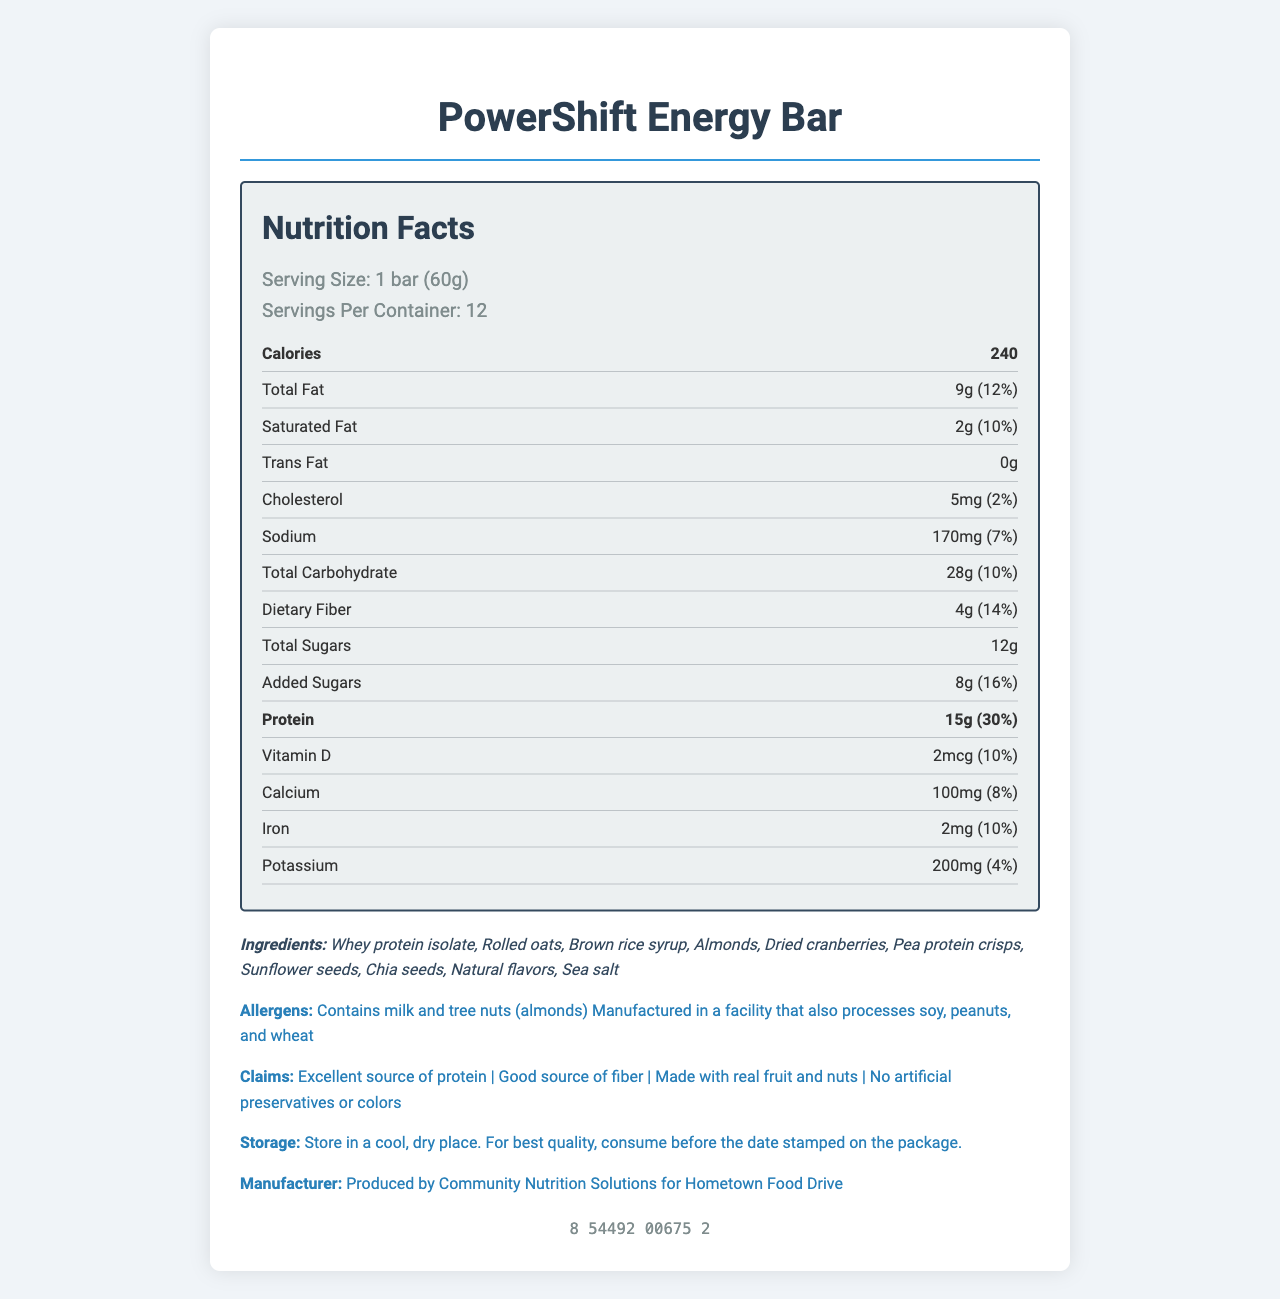What is the serving size for the PowerShift Energy Bar? The document specifies that the serving size of the PowerShift Energy Bar is "1 bar (60g)" under the 'serving info' section.
Answer: 1 bar (60g) How many servings are there per container? The document states there are 12 servings per container, as seen under the 'serving info' section.
Answer: 12 How many calories are there per serving? The document specifies that there are 240 calories per serving in the 'nutrition label' section.
Answer: 240 What are the total fat and its daily value percentage per serving? The document states that the total fat content per serving is 9g and this represents 12% of the daily value.
Answer: 9g (12%) What are the dietary fiber and its daily value percentage per serving? The document shows that the dietary fiber content per serving is 4g, which is 14% of the daily value.
Answer: 4g (14%) What ingredients does the PowerShift Energy Bar contain? The document lists the ingredients under the 'ingredients' section.
Answer: Whey protein isolate, Rolled oats, Brown rice syrup, Almonds, Dried cranberries, Pea protein crisps, Sunflower seeds, Chia seeds, Natural flavors, Sea salt What allergens are identified in the product? The document states the allergens in the 'allergens' section.
Answer: Contains milk and tree nuts (almonds), Manufactured in a facility that also processes soy, peanuts, and wheat Which vitamin's daily value percentage is the highest per serving? A. Vitamin D B. Calcium C. Iron D. Potassium The document indicates that Vitamin D has a daily value of 10%, Calcium has 8%, Iron has 10%, and Potassium has 4%. Vitamin D is the highest.
Answer: A. Vitamin D Which of the following claims is made about the PowerShift Energy Bar? I. Excellent source of protein II. Low in sodium III. No artificial preservatives or colors IV. Contains peanuts The document lists "Excellent source of protein" and "No artificial preservatives or colors" under the 'claims' section. "Low in sodium" and "Contains peanuts" are not included.
Answer: I, III Is the PowerShift Energy Bar a good source of protein? The document includes the claim "Excellent source of protein" under the 'claims' section and shows that it provides 15g of protein per serving, which is 30% of the daily value.
Answer: Yes Summarize the nutritional profile and key details of the PowerShift Energy Bar. This summary provides an overview of the nutritional content along with key ingredients, claims, and manufacturer information.
Answer: The PowerShift Energy Bar is a protein-rich energy bar with 240 calories per serving, containing 9g of total fat, 15g of protein, and 28g of carbohydrates per serving. It includes several ingredients like whey protein isolate, rolled oats, and dried cranberries. The bar is manufactured by Community Nutrition Solutions for Hometown Food Drive. Claims include an excellent source of protein, good source of fiber, made with real fruit and nuts, and no artificial preservatives or colors. What is the expiration date of the PowerShift Energy Bar? The document does not provide any information regarding an expiration date. Instead, it instructs to consume before the stamped date on the package.
Answer: Cannot be determined 